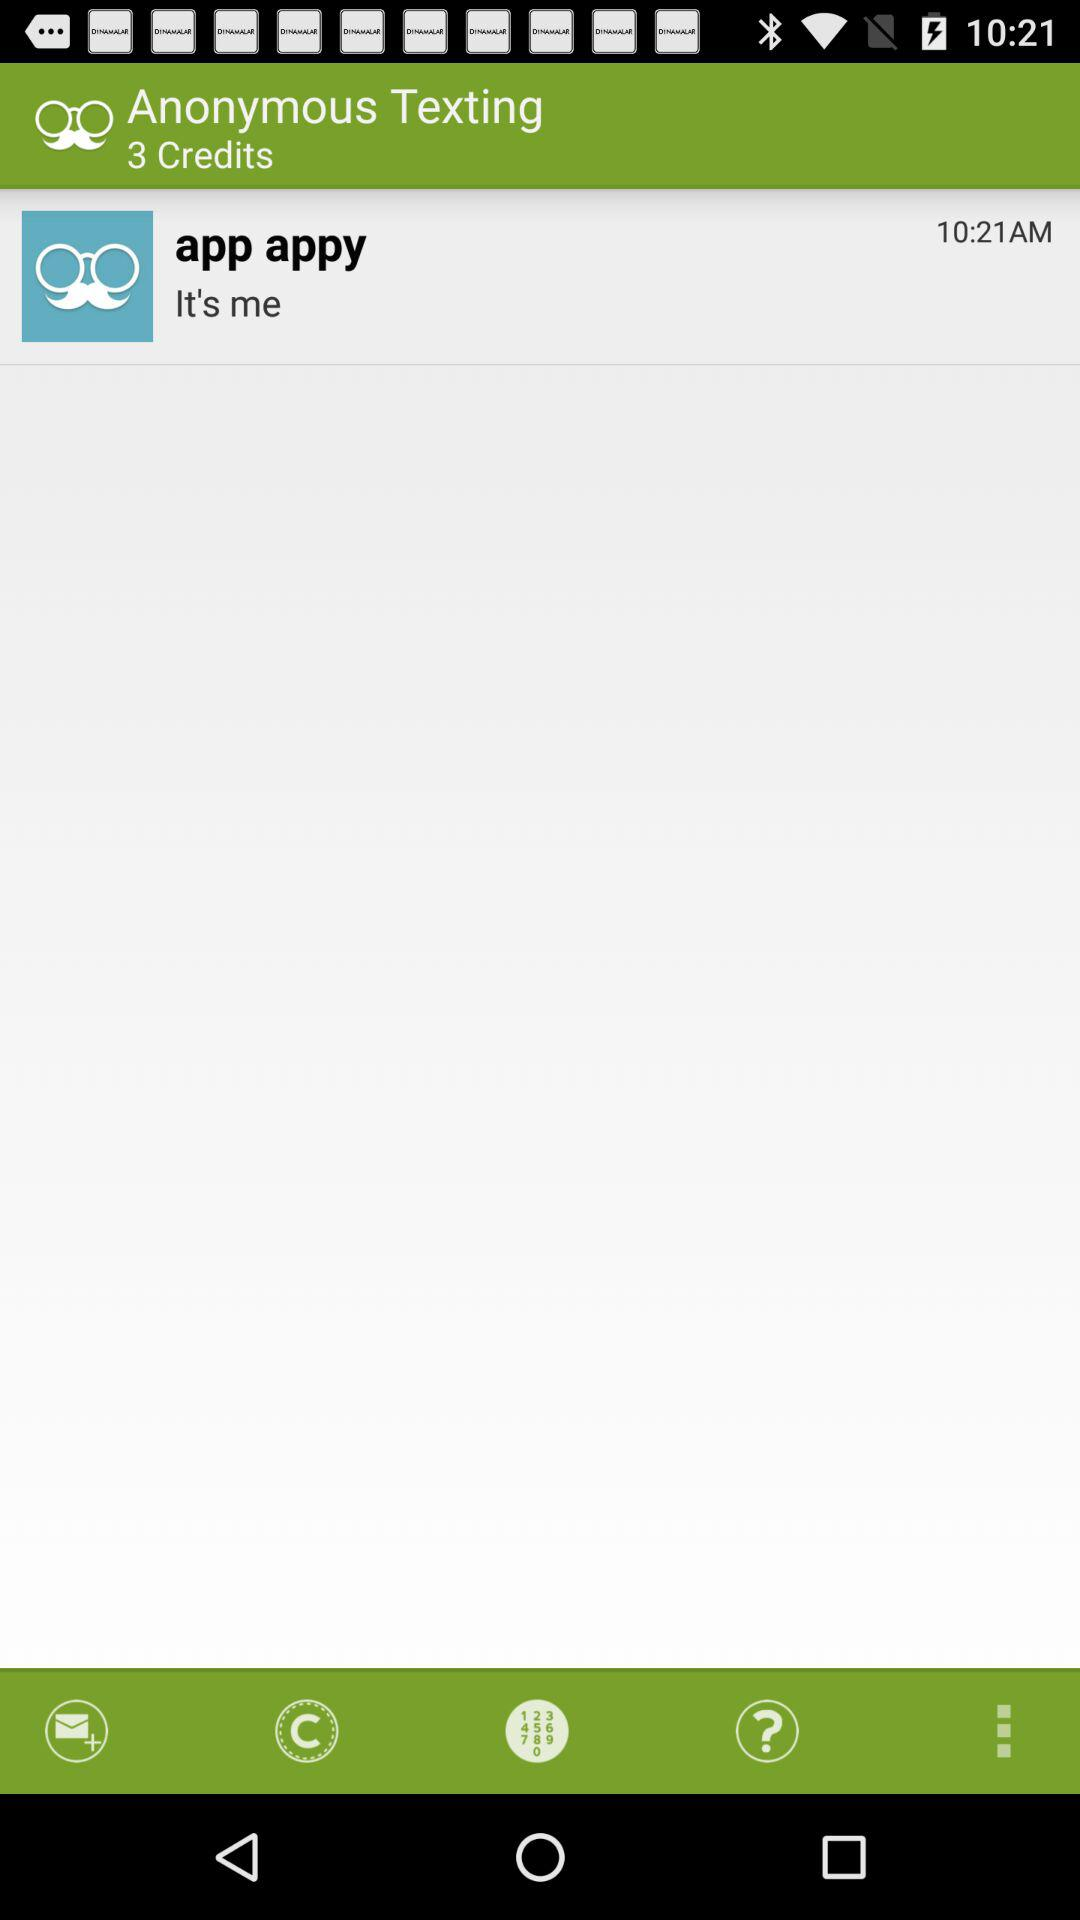What is the time?
Answer the question using a single word or phrase. 10:21 AM 